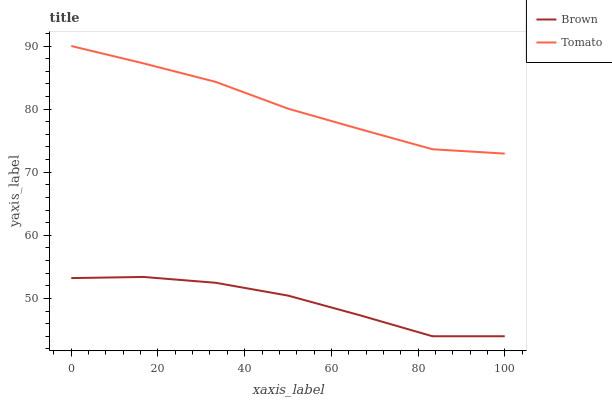Does Brown have the minimum area under the curve?
Answer yes or no. Yes. Does Tomato have the maximum area under the curve?
Answer yes or no. Yes. Does Brown have the maximum area under the curve?
Answer yes or no. No. Is Tomato the smoothest?
Answer yes or no. Yes. Is Brown the roughest?
Answer yes or no. Yes. Is Brown the smoothest?
Answer yes or no. No. Does Brown have the lowest value?
Answer yes or no. Yes. Does Tomato have the highest value?
Answer yes or no. Yes. Does Brown have the highest value?
Answer yes or no. No. Is Brown less than Tomato?
Answer yes or no. Yes. Is Tomato greater than Brown?
Answer yes or no. Yes. Does Brown intersect Tomato?
Answer yes or no. No. 